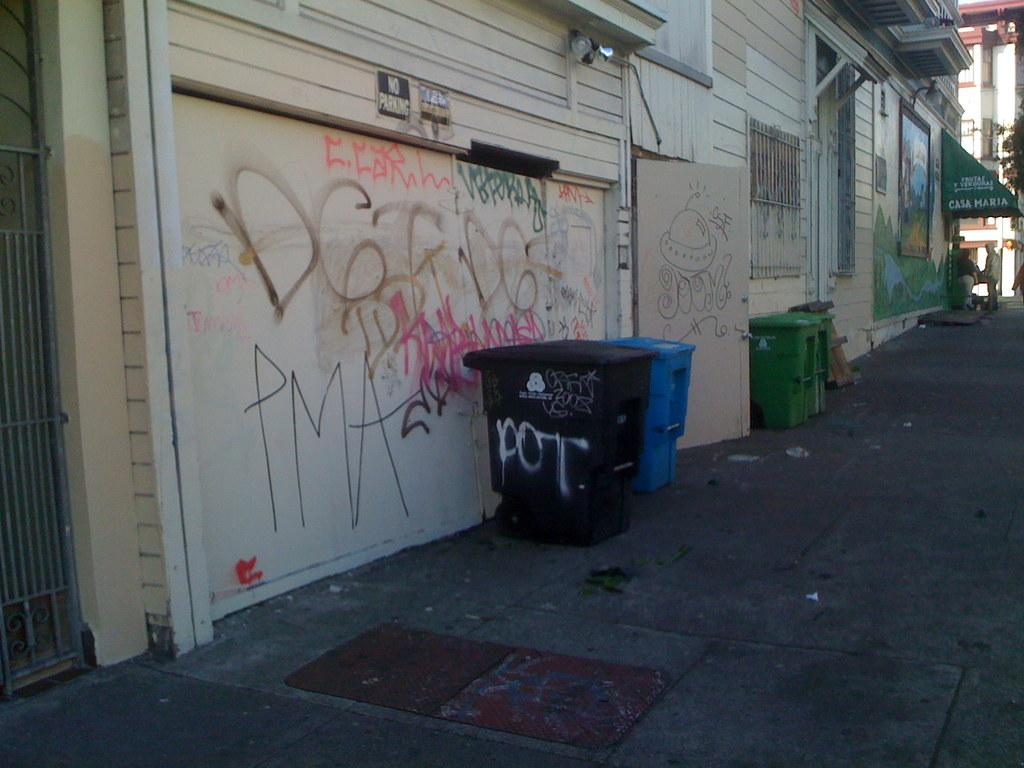<image>
Render a clear and concise summary of the photo. A dirty walkway with a closed store front and a black trash can nearby that has pot spray painted on its side. 